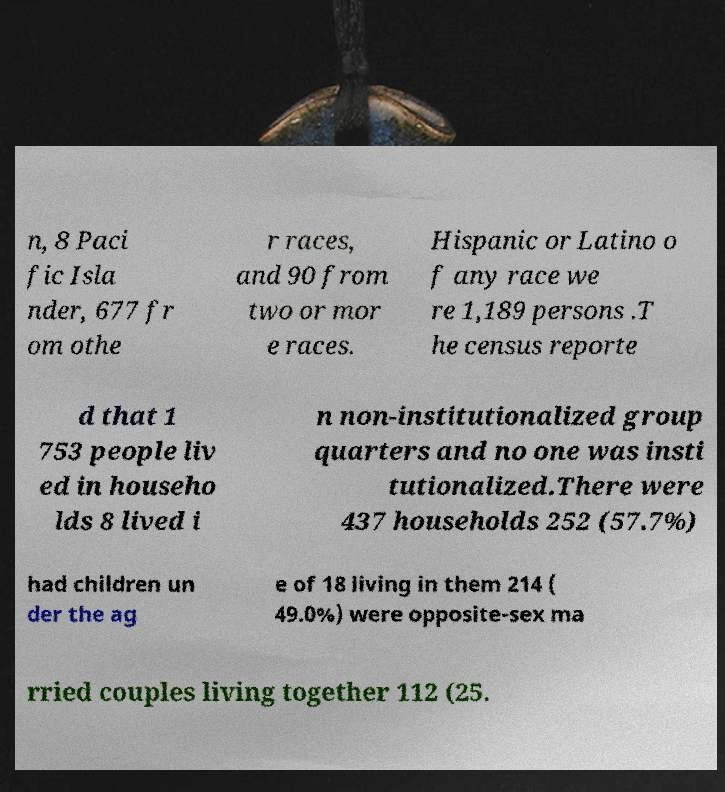Could you extract and type out the text from this image? n, 8 Paci fic Isla nder, 677 fr om othe r races, and 90 from two or mor e races. Hispanic or Latino o f any race we re 1,189 persons .T he census reporte d that 1 753 people liv ed in househo lds 8 lived i n non-institutionalized group quarters and no one was insti tutionalized.There were 437 households 252 (57.7%) had children un der the ag e of 18 living in them 214 ( 49.0%) were opposite-sex ma rried couples living together 112 (25. 